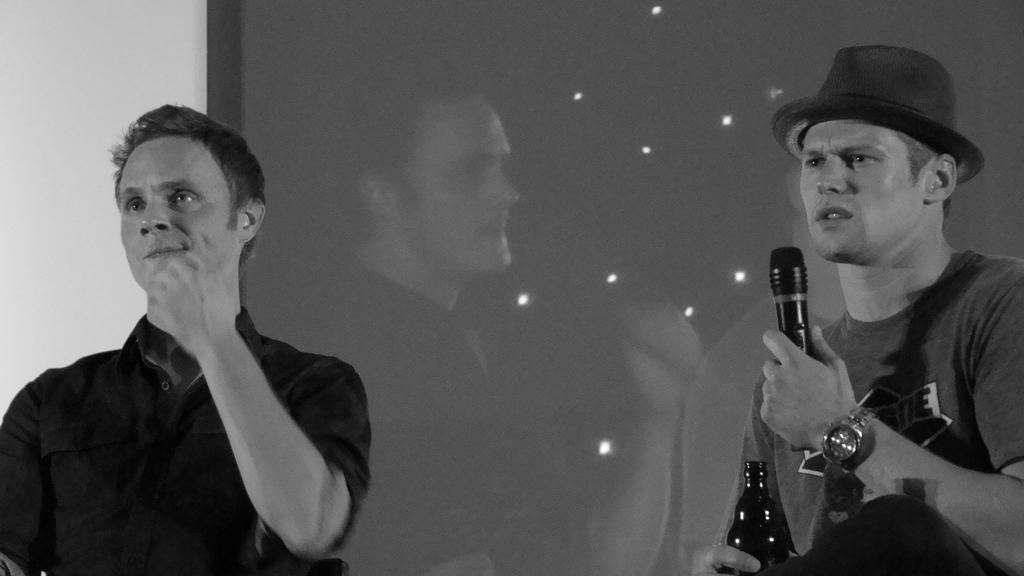In one or two sentences, can you explain what this image depicts? A person on the right is wearing a hat and watch and holding a bottle and mic. Also there is another person on the left is wearing a shirt and standing. In the back there is a screen. 